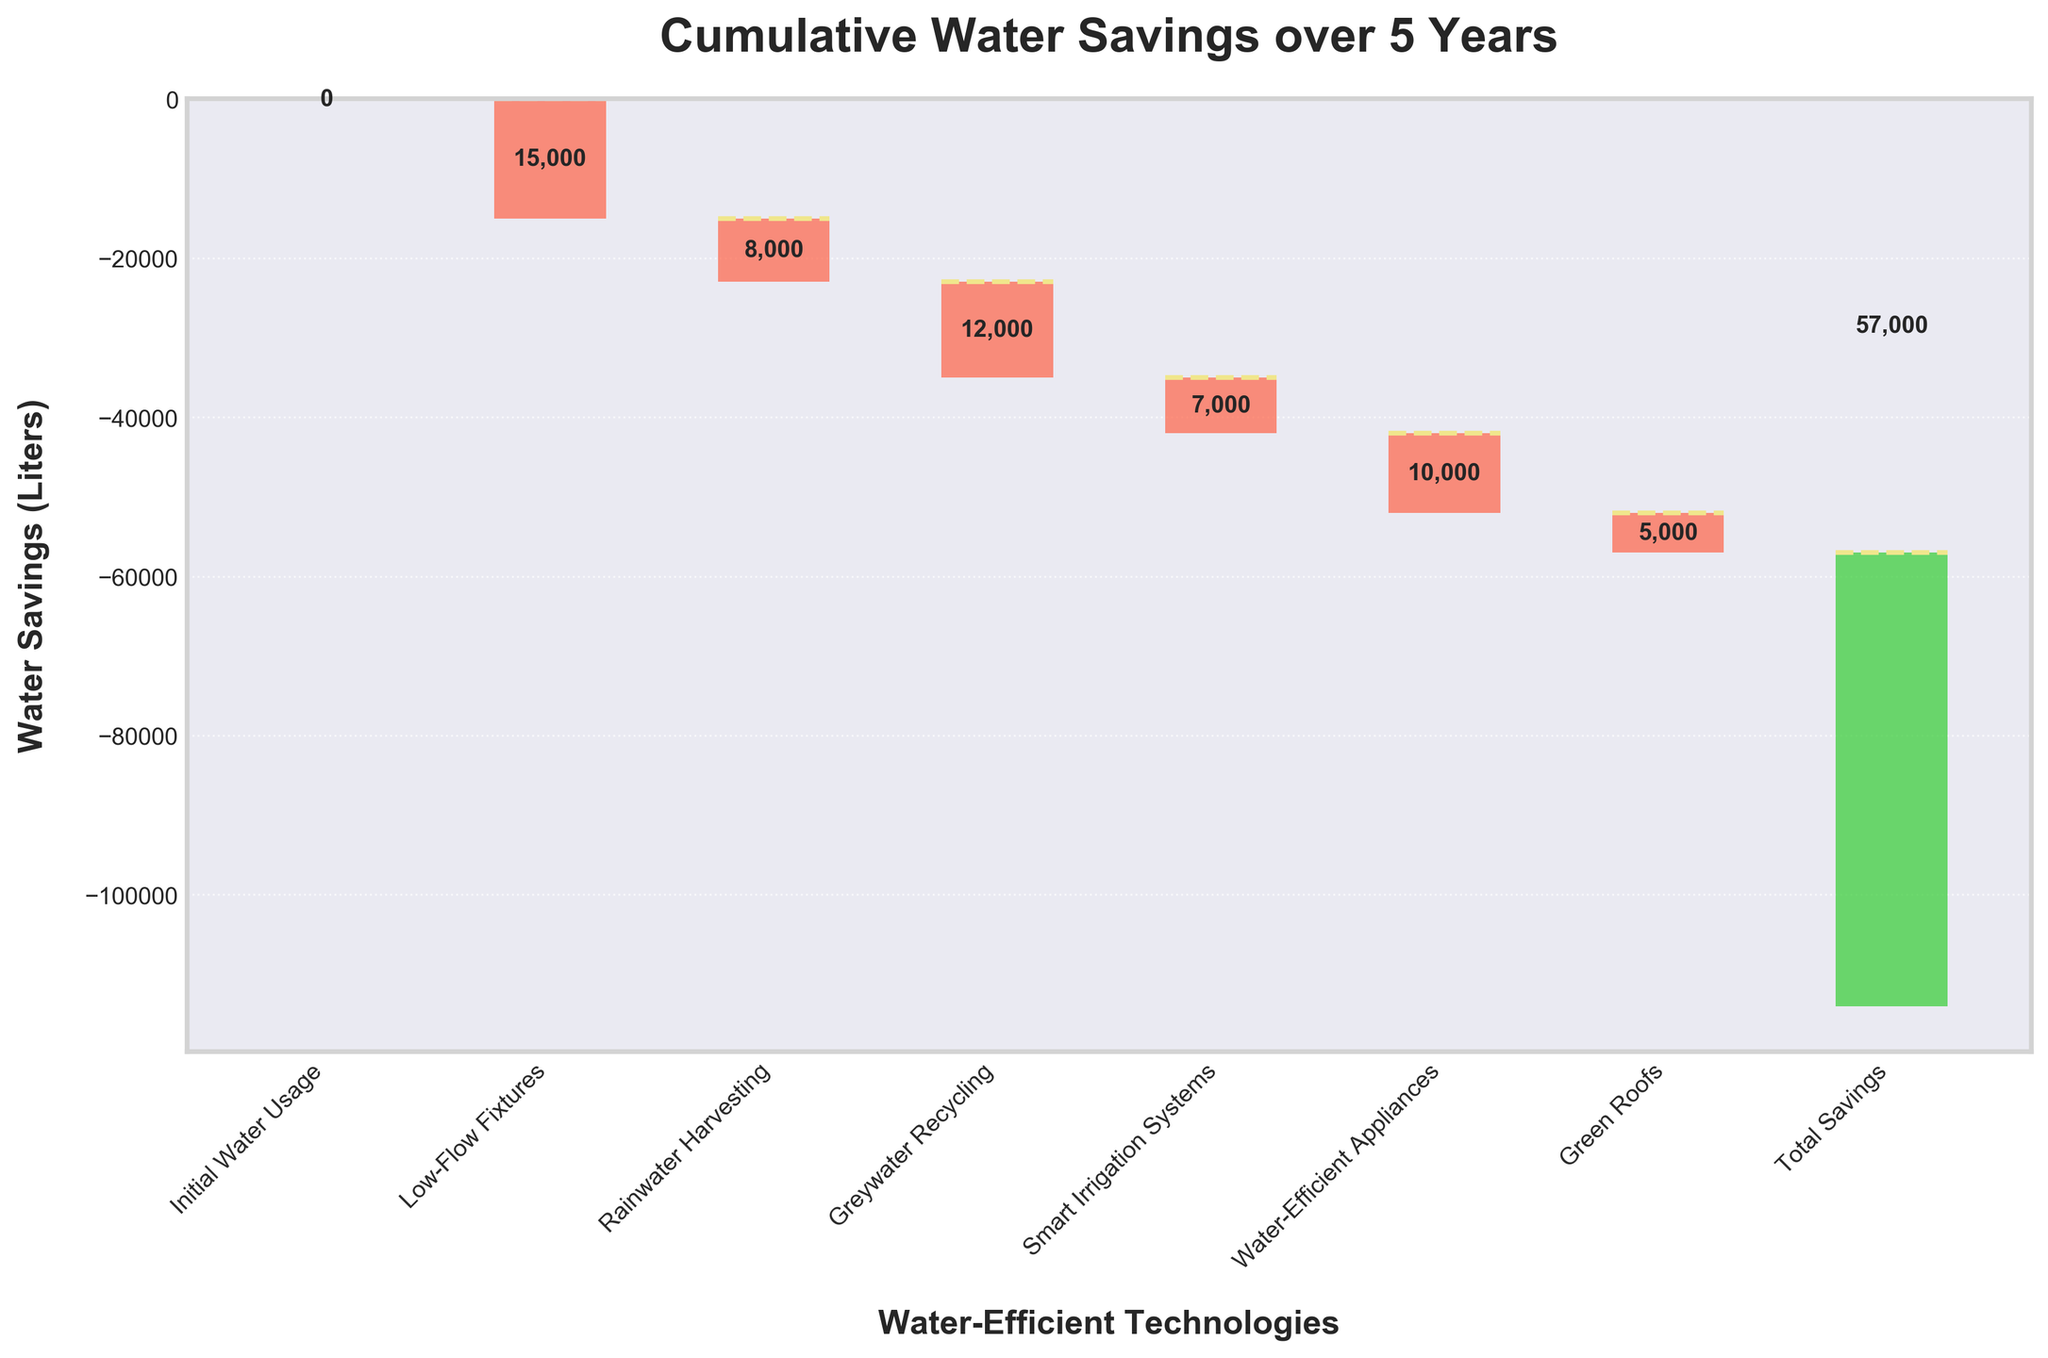What is the title of the figure? The title is usually located at the top of the figure. It provides a summary of what the figure represents. In this case, the title is "Cumulative Water Savings over 5 Years".
Answer: Cumulative Water Savings over 5 Years How many categories of water-efficient technologies are shown in the figure? To find the number of categories, count the labels on the x-axis.
Answer: 7 What is the initial water usage value shown in the figure? The initial water usage value can be spotted as the first bar in the chart. It is not decreased, so its value remains as 0.
Answer: 0 Which category resulted in the highest water savings? Compare each bar representing the different technologies and identify the one with the longest downward bar. The longest bar belongs to "Low-Flow Fixtures" with a savings of -15,000 liters.
Answer: Low-Flow Fixtures What is the total cumulative water savings at the end of the 5-year period? The final label on the x-axis represents the total cumulative water savings. This can be seen next to "Total Savings".
Answer: -57,000 liters How much water was saved through rainwater harvesting and greywater recycling combined? Look at the savings from both Rainwater Harvesting (-8,000 liters) and Greywater Recycling (-12,000 liters), and sum them up: -8,000 + -12,000 = -20,000 liters.
Answer: -20,000 liters Which technology contributed more to water savings: Smart Irrigation Systems or Green Roofs? Compare the water savings values for Smart Irrigation Systems (-7,000 liters) and Green Roofs (-5,000 liters).
Answer: Smart Irrigation Systems What is the difference in water savings between water-efficient appliances and green roofs? Subtract the water savings of Green Roofs (-5,000 liters) from Water-Efficient Appliances (-10,000 liters): -10,000 - (-5,000) = -5,000 liters.
Answer: -5,000 liters Which technology showed the smallest water savings? Compare all the bars and identify the smallest downward bar. Green Roofs have the smallest savings with -5,000 liters.
Answer: Green Roofs If the savings from low-flow fixtures were doubled, what would the revised total cumulative water savings be? First, find the doubled savings for Low-Flow Fixtures: 2 * -15,000 = -30,000 liters. Subtract the original savings and add the doubled savings to the original total: -57,000 - (-15,000) + (-30,000) = -72,000 liters.
Answer: -72,000 liters 